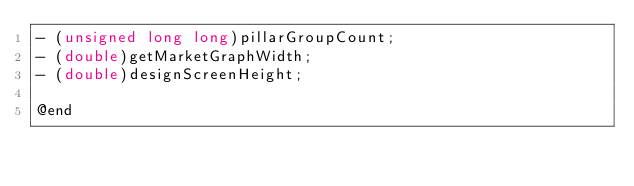<code> <loc_0><loc_0><loc_500><loc_500><_C_>- (unsigned long long)pillarGroupCount;
- (double)getMarketGraphWidth;
- (double)designScreenHeight;

@end

</code> 